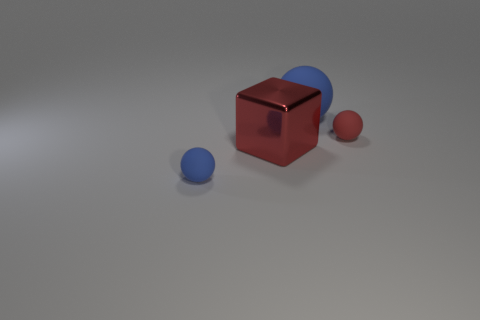There is a red thing that is the same material as the big blue ball; what shape is it?
Give a very brief answer. Sphere. There is a tiny rubber object that is to the left of the big matte thing; is it the same color as the tiny matte object that is behind the small blue ball?
Your response must be concise. No. What number of gray things are big shiny cubes or large rubber balls?
Your answer should be compact. 0. Is the number of cubes that are right of the metal object less than the number of red rubber balls that are on the left side of the small blue rubber ball?
Your answer should be compact. No. Are there any blue matte things that have the same size as the cube?
Make the answer very short. Yes. Do the blue object on the left side of the metallic block and the small red sphere have the same size?
Your answer should be compact. Yes. Is the number of shiny things greater than the number of brown metal cubes?
Your answer should be very brief. Yes. Are there any other things that have the same shape as the tiny blue object?
Ensure brevity in your answer.  Yes. What is the shape of the blue object that is behind the red rubber thing?
Your response must be concise. Sphere. There is a thing that is on the right side of the blue rubber ball that is behind the tiny red matte ball; how many blue rubber things are behind it?
Offer a very short reply. 1. 